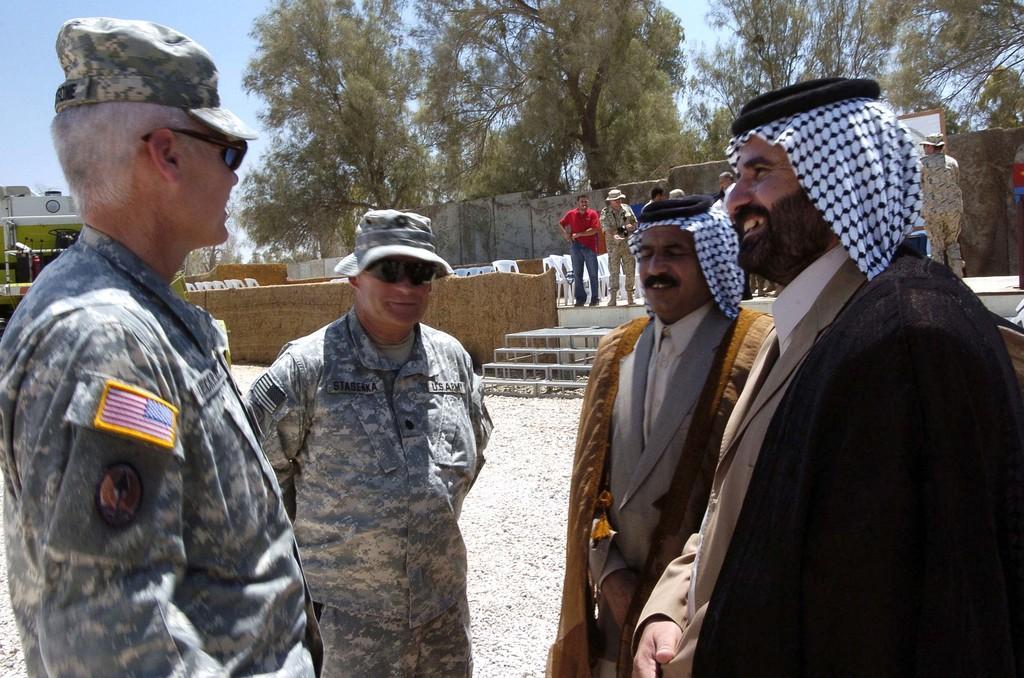Can you describe this image briefly? In this image there are people. We can see some of them are wearing uniforms. There are chairs and walls we can see trees. In the background there is sky. 